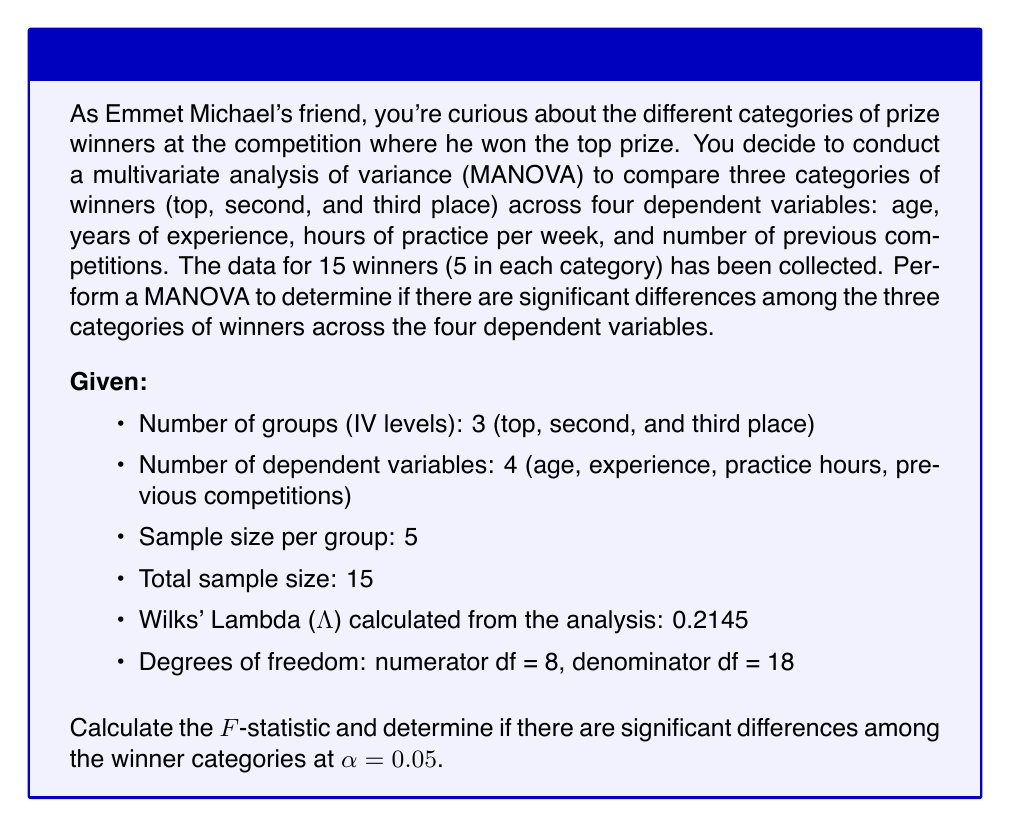Help me with this question. To perform a MANOVA and interpret the results, we'll follow these steps:

1. State the null and alternative hypotheses:
   $H_0$: There are no significant differences among the winner categories across the dependent variables.
   $H_a$: There are significant differences among the winner categories across the dependent variables.

2. Calculate the F-statistic using Wilks' Lambda (Λ):
   The F-statistic for Wilks' Lambda is calculated using the following formula:

   $$F = \frac{1-\Lambda^{\frac{1}{t}}}{\Lambda^{\frac{1}{t}}} \cdot \frac{df_e - \frac{p-g+1}{2}}{p}$$

   Where:
   - Λ = Wilks' Lambda
   - $t = \sqrt{\frac{p^2(g-1)^2-4}{p^2+(g-1)^2-5}}$ (for $p^2+(g-1)^2 > 5$)
   - $p$ = number of dependent variables
   - $g$ = number of groups
   - $df_e$ = error degrees of freedom (denominator df)

3. Calculate $t$:
   $$t = \sqrt{\frac{4^2(3-1)^2-4}{4^2+(3-1)^2-5}} = \sqrt{\frac{64-4}{16+4-5}} = \sqrt{\frac{60}{15}} = 2$$

4. Calculate the F-statistic:
   $$F = \frac{1-0.2145^{\frac{1}{2}}}{0.2145^{\frac{1}{2}}} \cdot \frac{18 - \frac{4-3+1}{2}}{4}$$
   $$F = \frac{1-0.4631}{0.4631} \cdot \frac{18 - 1}{4}$$
   $$F = 1.1594 \cdot 4.25 = 4.9275$$

5. Determine the critical F-value:
   For α = 0.05, numerator df = 8, and denominator df = 18, the critical F-value is approximately 2.51 (obtained from an F-distribution table or calculator).

6. Compare the calculated F-statistic to the critical F-value:
   Since 4.9275 > 2.51, we reject the null hypothesis.

7. Interpret the results:
   The MANOVA results indicate that there are significant differences among the three categories of winners (top, second, and third place) across the four dependent variables (age, years of experience, hours of practice per week, and number of previous competitions) at the α = 0.05 level.
Answer: F-statistic = 4.9275
Conclusion: Reject the null hypothesis. There are significant differences among the winner categories across the dependent variables (p < 0.05). 